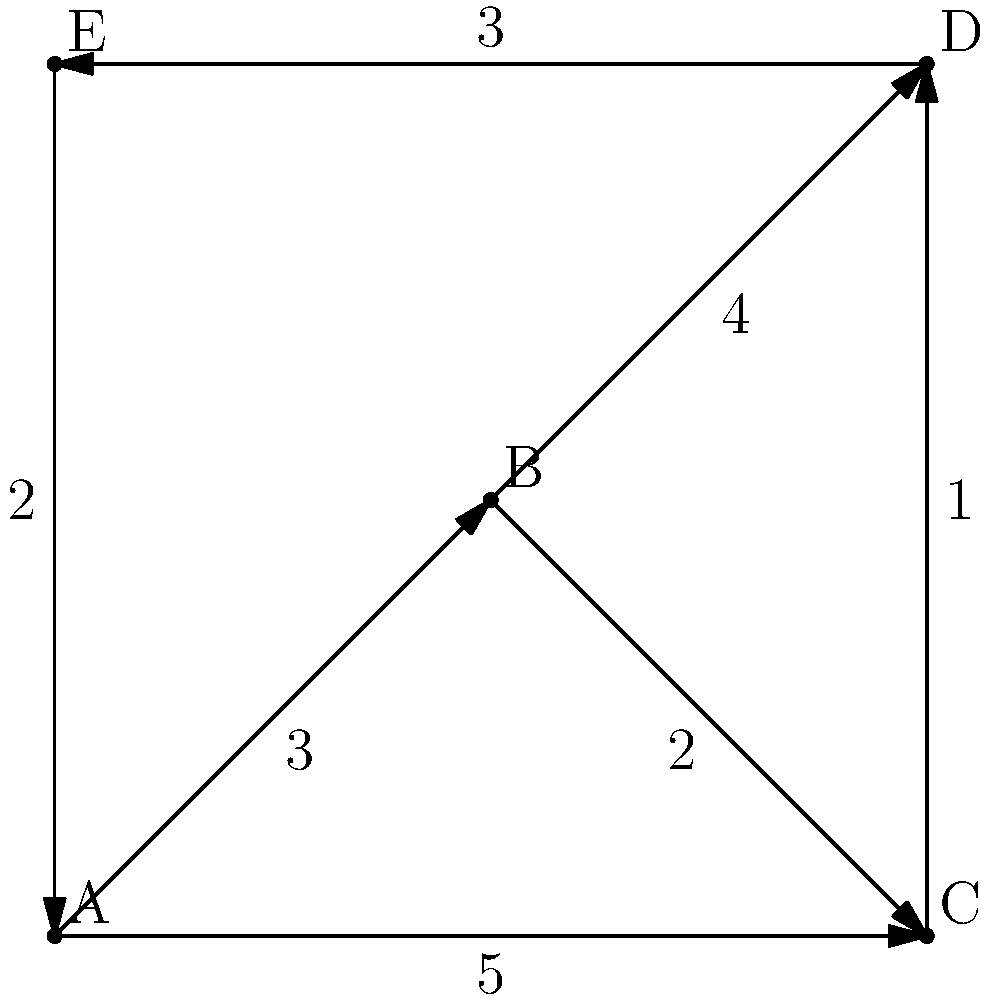As a stamp distribution expert, you're tasked with finding the most efficient route to deliver limited edition stamps to all post offices in a region. The weighted graph represents the distribution network, where vertices are post offices and edge weights indicate delivery times in hours. What is the minimum time required to visit all post offices starting from office A and returning to A, visiting each office exactly once? To solve this problem, we need to find the Hamiltonian cycle with the minimum total weight in the given graph. This is known as the Traveling Salesman Problem (TSP). Here's how we can approach it:

1. Identify all possible Hamiltonian cycles starting and ending at A:
   - A → B → C → D → E → A
   - A → B → D → C → E → A
   - A → B → D → E → C → A
   - A → E → D → C → B → A
   - A → E → D → B → C → A

2. Calculate the total weight (time) for each cycle:
   - A → B → C → D → E → A: 3 + 2 + 1 + 3 + 2 = 11 hours
   - A → B → D → C → E → A: 3 + 4 + 1 + 5 + 2 = 15 hours
   - A → B → D → E → C → A: 3 + 4 + 3 + 5 = 15 hours
   - A → E → D → C → B → A: 2 + 3 + 1 + 2 + 3 = 11 hours
   - A → E → D → B → C → A: 2 + 3 + 4 + 2 + 5 = 16 hours

3. Identify the cycle(s) with the minimum total weight:
   Two cycles have the minimum weight of 11 hours:
   - A → B → C → D → E → A
   - A → E → D → C → B → A

Therefore, the minimum time required to visit all post offices, starting and ending at A, while visiting each office exactly once, is 11 hours.
Answer: 11 hours 